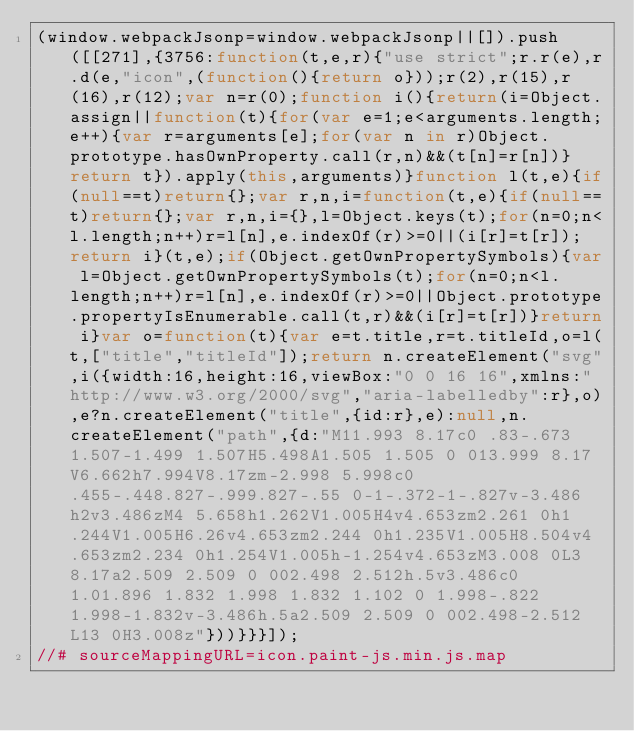Convert code to text. <code><loc_0><loc_0><loc_500><loc_500><_JavaScript_>(window.webpackJsonp=window.webpackJsonp||[]).push([[271],{3756:function(t,e,r){"use strict";r.r(e),r.d(e,"icon",(function(){return o}));r(2),r(15),r(16),r(12);var n=r(0);function i(){return(i=Object.assign||function(t){for(var e=1;e<arguments.length;e++){var r=arguments[e];for(var n in r)Object.prototype.hasOwnProperty.call(r,n)&&(t[n]=r[n])}return t}).apply(this,arguments)}function l(t,e){if(null==t)return{};var r,n,i=function(t,e){if(null==t)return{};var r,n,i={},l=Object.keys(t);for(n=0;n<l.length;n++)r=l[n],e.indexOf(r)>=0||(i[r]=t[r]);return i}(t,e);if(Object.getOwnPropertySymbols){var l=Object.getOwnPropertySymbols(t);for(n=0;n<l.length;n++)r=l[n],e.indexOf(r)>=0||Object.prototype.propertyIsEnumerable.call(t,r)&&(i[r]=t[r])}return i}var o=function(t){var e=t.title,r=t.titleId,o=l(t,["title","titleId"]);return n.createElement("svg",i({width:16,height:16,viewBox:"0 0 16 16",xmlns:"http://www.w3.org/2000/svg","aria-labelledby":r},o),e?n.createElement("title",{id:r},e):null,n.createElement("path",{d:"M11.993 8.17c0 .83-.673 1.507-1.499 1.507H5.498A1.505 1.505 0 013.999 8.17V6.662h7.994V8.17zm-2.998 5.998c0 .455-.448.827-.999.827-.55 0-1-.372-1-.827v-3.486h2v3.486zM4 5.658h1.262V1.005H4v4.653zm2.261 0h1.244V1.005H6.26v4.653zm2.244 0h1.235V1.005H8.504v4.653zm2.234 0h1.254V1.005h-1.254v4.653zM3.008 0L3 8.17a2.509 2.509 0 002.498 2.512h.5v3.486c0 1.01.896 1.832 1.998 1.832 1.102 0 1.998-.822 1.998-1.832v-3.486h.5a2.509 2.509 0 002.498-2.512L13 0H3.008z"}))}}}]);
//# sourceMappingURL=icon.paint-js.min.js.map</code> 